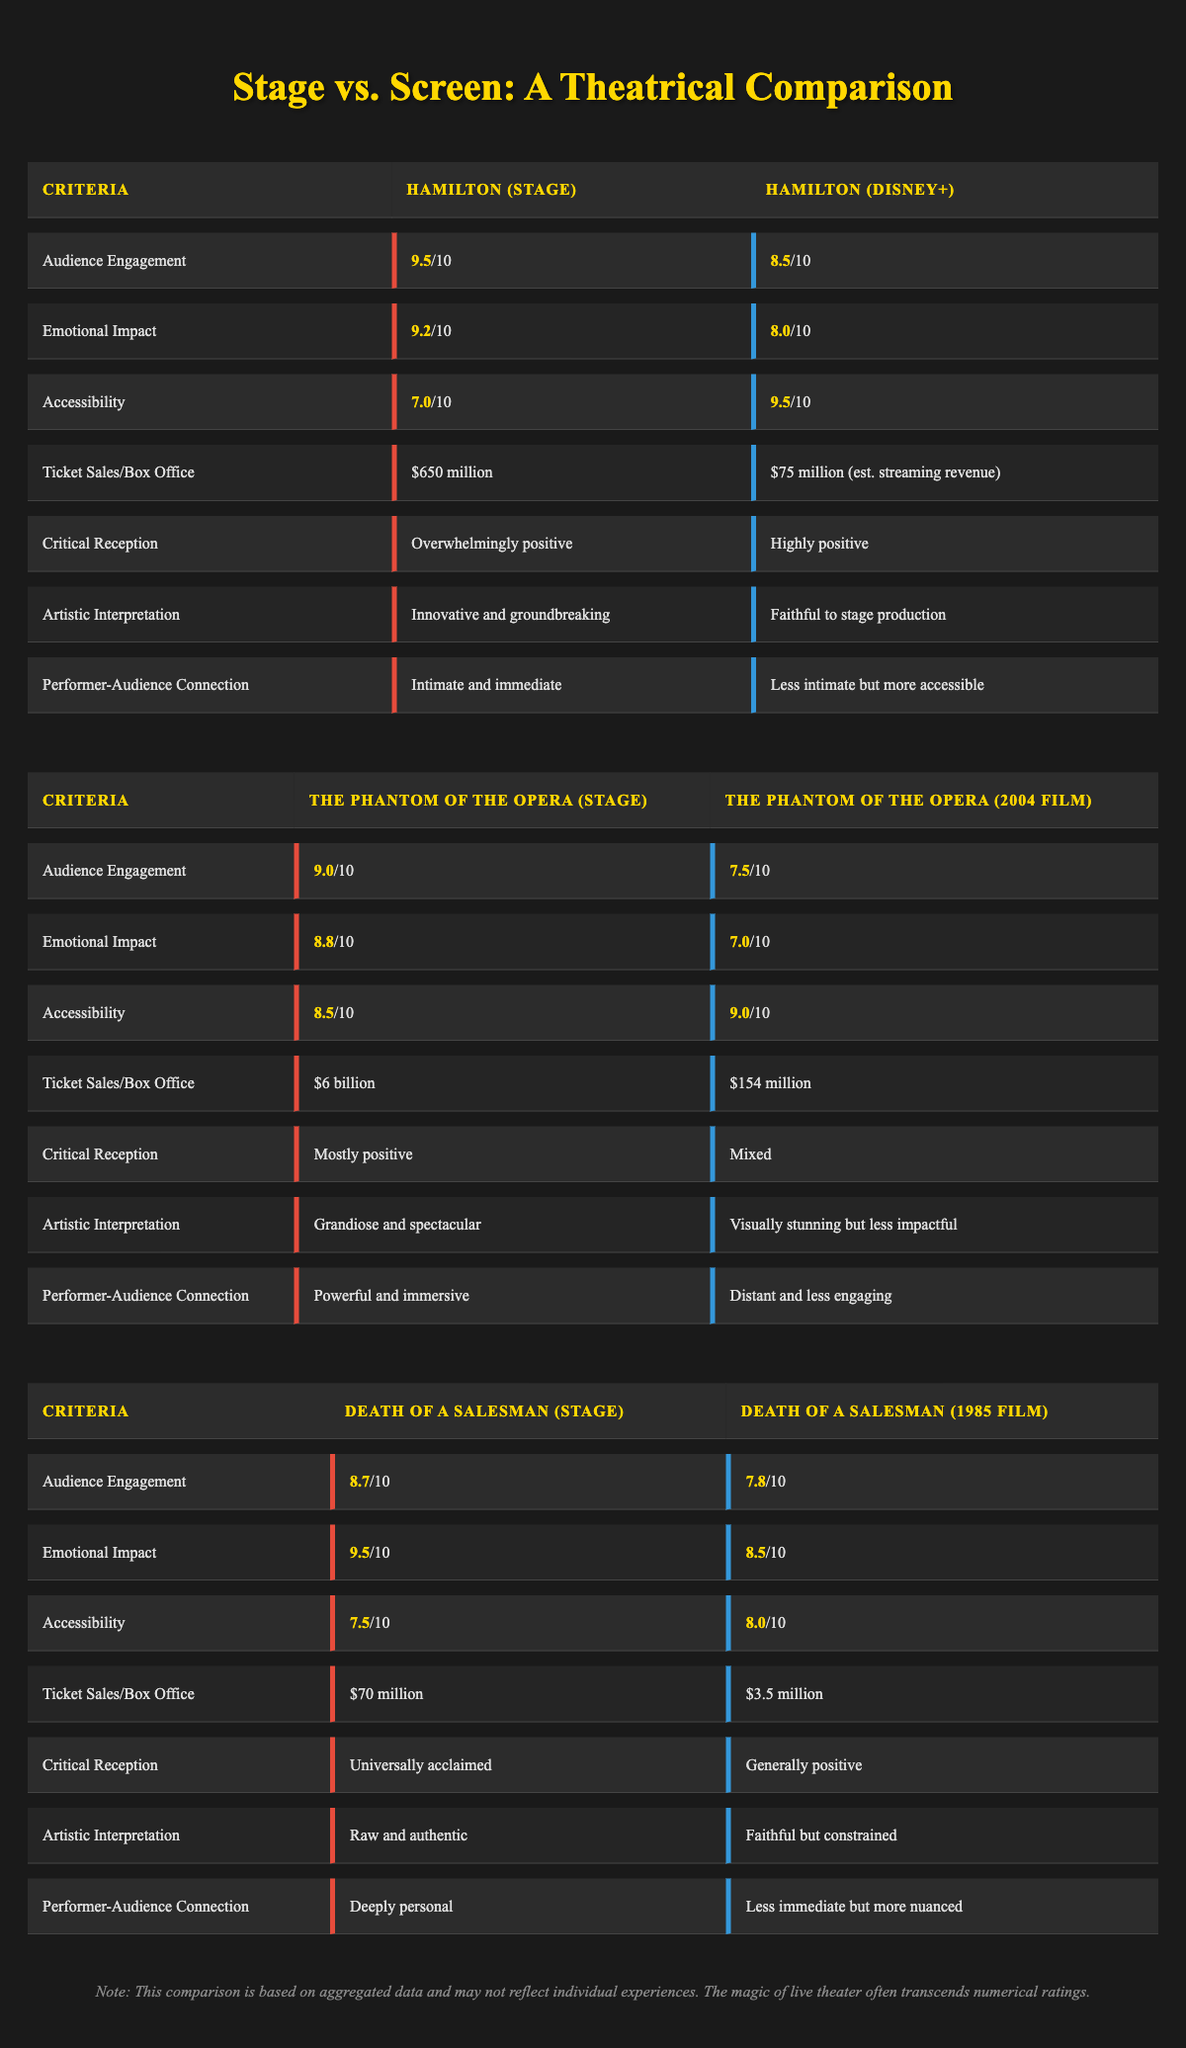What is the emotional impact rating for "Hamilton" as a stage play? The emotional impact rating for "Hamilton" in the stage play category is listed under that title's row, which is 9.2/10.
Answer: 9.2 How much were the ticket sales for "Death of a Salesman" on stage? The ticket sales for "Death of a Salesman" in the stage play category is specifically noted as $70 million.
Answer: $70 million Which adaptation had a higher audience engagement: "The Phantom of the Opera" stage play or its film adaptation? The stage play version of "The Phantom of the Opera" has an audience engagement rating of 9.0 while the film adaptation has a rating of 7.5, making the stage version higher.
Answer: Stage play What is the difference in emotional impact rating between "Death of a Salesman" stage play and its film adaptation? The emotional impact for the stage version is 9.5 and for the film it's 8.5. To find the difference, calculate 9.5 - 8.5, which equals 1.0.
Answer: 1.0 Is the critical reception of the film adaptation of "Hamilton" lower than that of its stage version? The stage version of "Hamilton" received an overwhelmingly positive critical reception, whereas the film adaptation received a highly positive review. This indicates that the film's reception is lower than that of the stage.
Answer: Yes What is the average ticket sales for the three stage plays listed? The ticket sales for each stage play are $650 million, $6 billion, and $70 million. First, convert $6 billion to millions (which is $6,000 million), then sum them: 650 + 6000 + 70 = 6720. Divide by 3 to get the average: 6720/3 = 2240 million.
Answer: $2240 million How does "Hamilton" (Disney+) compare in accessibility to "Death of a Salesman" (1985 film)? The accessibility rating for "Hamilton" (Disney+) is 9.5, while for "Death of a Salesman" (1985 film) it is 8.0. Since 9.5 is greater than 8.0, "Hamilton" (Disney+) is more accessible than "Death of a Salesman" (1985 film).
Answer: More accessible What was the audience engagement rating for the stage version of "Death of a Salesman"? The audience engagement rating for "Death of a Salesman" in the stage play category is listed as 8.7/10 in the table.
Answer: 8.7 Which film adaptation had the highest ticket sales compared to its stage play? Among the adaptations, "The Phantom of the Opera" film had ticket sales of $154 million compared to the stage's $6 billion, which is significantly higher. However, since both belong to different formats, the ticket sales of the stage play are not just higher but vastly larger.
Answer: Stage play 